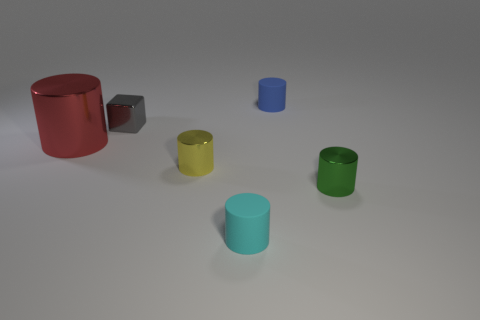What is the size of the rubber object in front of the rubber thing behind the big metal object?
Your response must be concise. Small. There is a tiny object that is right of the tiny cyan cylinder and behind the big shiny object; what is its material?
Offer a terse response. Rubber. The big metal cylinder is what color?
Offer a very short reply. Red. What is the shape of the metal thing that is in front of the yellow cylinder?
Provide a succinct answer. Cylinder. Is there a thing right of the tiny metallic cylinder that is left of the tiny cylinder on the right side of the small blue thing?
Your answer should be very brief. Yes. Is there anything else that has the same shape as the small cyan rubber object?
Provide a succinct answer. Yes. Is there a tiny blue block?
Provide a succinct answer. No. Is the material of the cylinder behind the gray metallic thing the same as the tiny cylinder to the left of the small cyan matte thing?
Ensure brevity in your answer.  No. There is a rubber cylinder behind the small cylinder to the right of the matte object that is behind the small cube; what is its size?
Provide a short and direct response. Small. What number of big blue cubes have the same material as the big thing?
Offer a terse response. 0. 